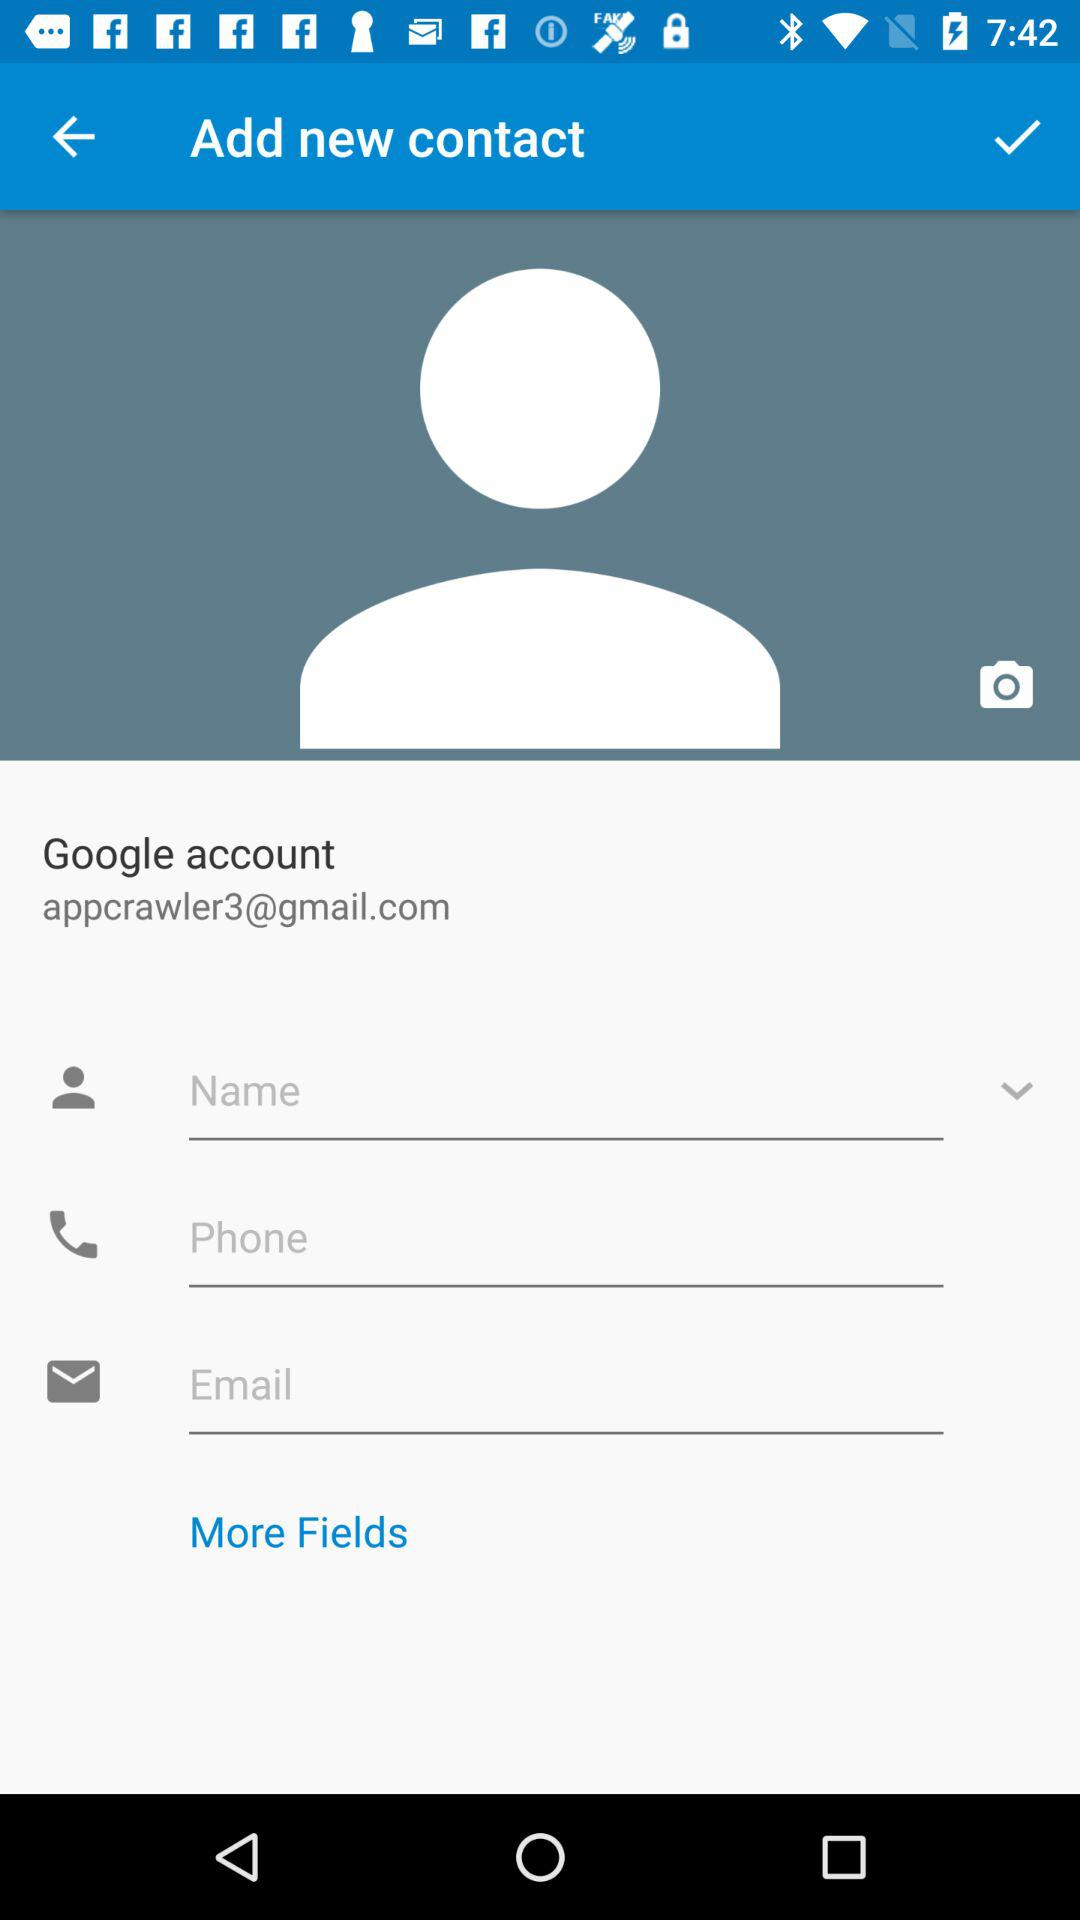On what application is the Gmail account created? The Gmail account was created on "Google". 